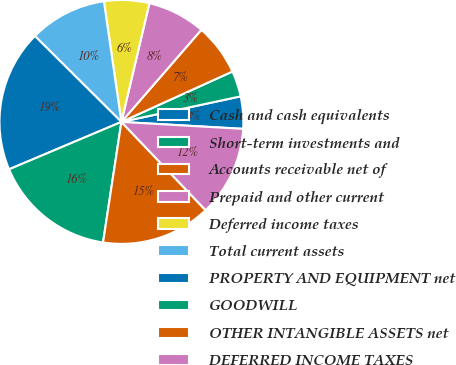Convert chart. <chart><loc_0><loc_0><loc_500><loc_500><pie_chart><fcel>Cash and cash equivalents<fcel>Short-term investments and<fcel>Accounts receivable net of<fcel>Prepaid and other current<fcel>Deferred income taxes<fcel>Total current assets<fcel>PROPERTY AND EQUIPMENT net<fcel>GOODWILL<fcel>OTHER INTANGIBLE ASSETS net<fcel>DEFERRED INCOME TAXES<nl><fcel>4.27%<fcel>3.42%<fcel>6.84%<fcel>7.69%<fcel>5.98%<fcel>10.26%<fcel>18.8%<fcel>16.24%<fcel>14.53%<fcel>11.97%<nl></chart> 